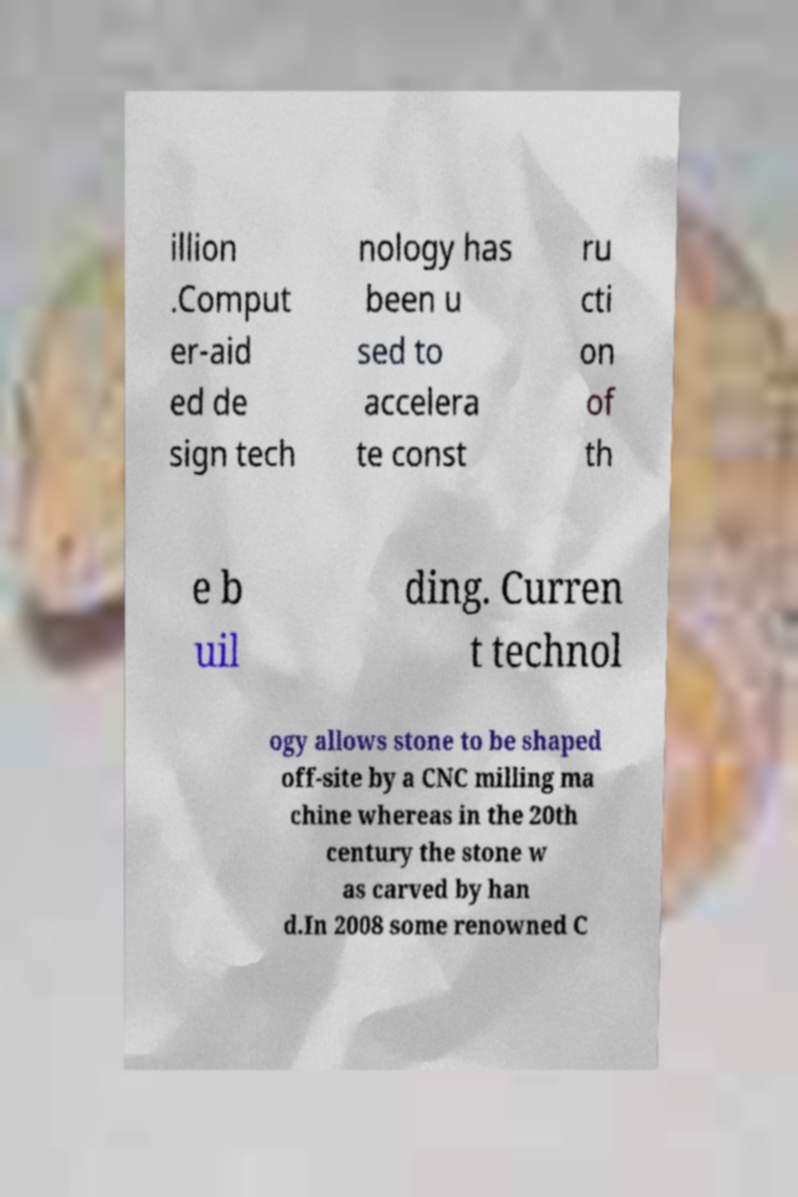I need the written content from this picture converted into text. Can you do that? illion .Comput er-aid ed de sign tech nology has been u sed to accelera te const ru cti on of th e b uil ding. Curren t technol ogy allows stone to be shaped off-site by a CNC milling ma chine whereas in the 20th century the stone w as carved by han d.In 2008 some renowned C 